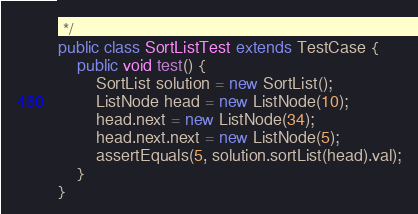<code> <loc_0><loc_0><loc_500><loc_500><_Java_> */
public class SortListTest extends TestCase {
    public void test() {
        SortList solution = new SortList();
        ListNode head = new ListNode(10);
        head.next = new ListNode(34);
        head.next.next = new ListNode(5);
        assertEquals(5, solution.sortList(head).val);
    }
}
</code> 